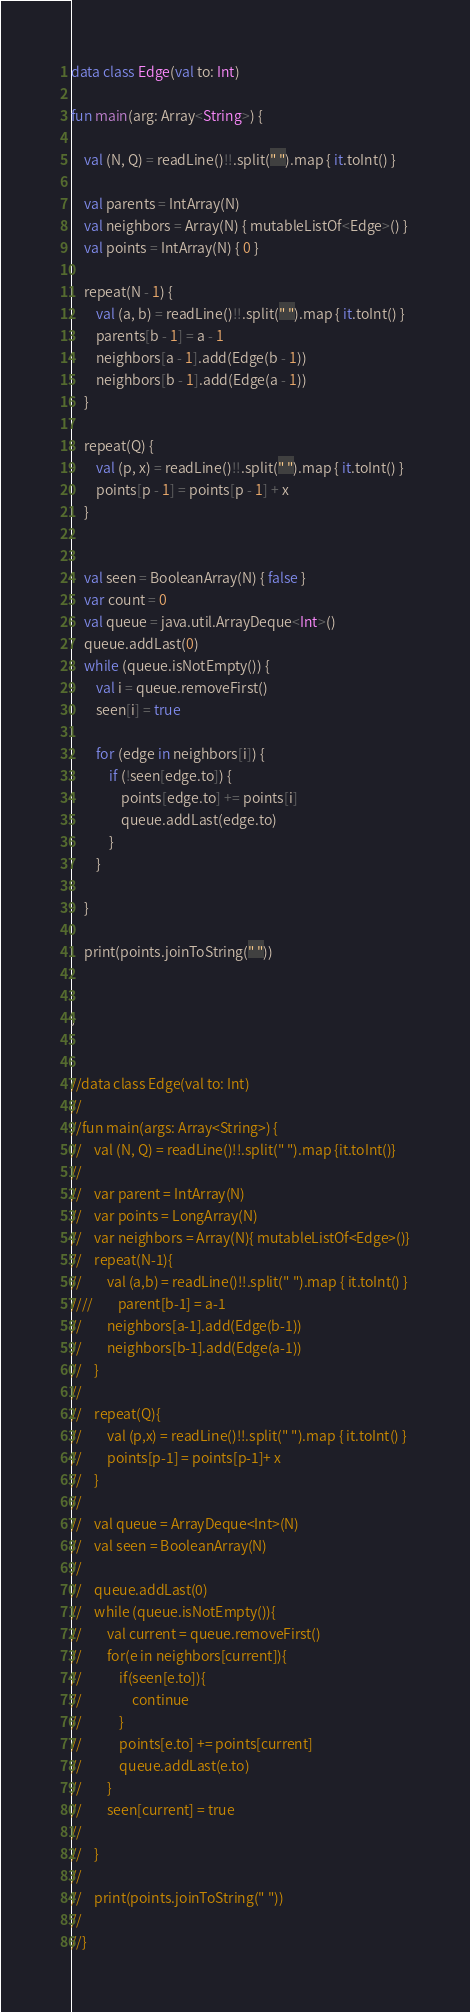Convert code to text. <code><loc_0><loc_0><loc_500><loc_500><_Kotlin_>data class Edge(val to: Int)

fun main(arg: Array<String>) {

    val (N, Q) = readLine()!!.split(" ").map { it.toInt() }

    val parents = IntArray(N)
    val neighbors = Array(N) { mutableListOf<Edge>() }
    val points = IntArray(N) { 0 }

    repeat(N - 1) {
        val (a, b) = readLine()!!.split(" ").map { it.toInt() }
        parents[b - 1] = a - 1
        neighbors[a - 1].add(Edge(b - 1))
        neighbors[b - 1].add(Edge(a - 1))
    }

    repeat(Q) {
        val (p, x) = readLine()!!.split(" ").map { it.toInt() }
        points[p - 1] = points[p - 1] + x
    }


    val seen = BooleanArray(N) { false }
    var count = 0
    val queue = java.util.ArrayDeque<Int>()
    queue.addLast(0)
    while (queue.isNotEmpty()) {
        val i = queue.removeFirst()
        seen[i] = true

        for (edge in neighbors[i]) {
            if (!seen[edge.to]) {
                points[edge.to] += points[i]
                queue.addLast(edge.to)
            }
        }

    }

    print(points.joinToString(" "))


}


//data class Edge(val to: Int)
//
//fun main(args: Array<String>) {
//    val (N, Q) = readLine()!!.split(" ").map {it.toInt()}
//
//    var parent = IntArray(N)
//    var points = LongArray(N)
//    var neighbors = Array(N){ mutableListOf<Edge>()}
//    repeat(N-1){
//        val (a,b) = readLine()!!.split(" ").map { it.toInt() }
////        parent[b-1] = a-1
//        neighbors[a-1].add(Edge(b-1))
//        neighbors[b-1].add(Edge(a-1))
//    }
//
//    repeat(Q){
//        val (p,x) = readLine()!!.split(" ").map { it.toInt() }
//        points[p-1] = points[p-1]+ x
//    }
//
//    val queue = ArrayDeque<Int>(N)
//    val seen = BooleanArray(N)
//
//    queue.addLast(0)
//    while (queue.isNotEmpty()){
//        val current = queue.removeFirst()
//        for(e in neighbors[current]){
//            if(seen[e.to]){
//                continue
//            }
//            points[e.to] += points[current]
//            queue.addLast(e.to)
//        }
//        seen[current] = true
//
//    }
//
//    print(points.joinToString(" "))
//
//}
</code> 